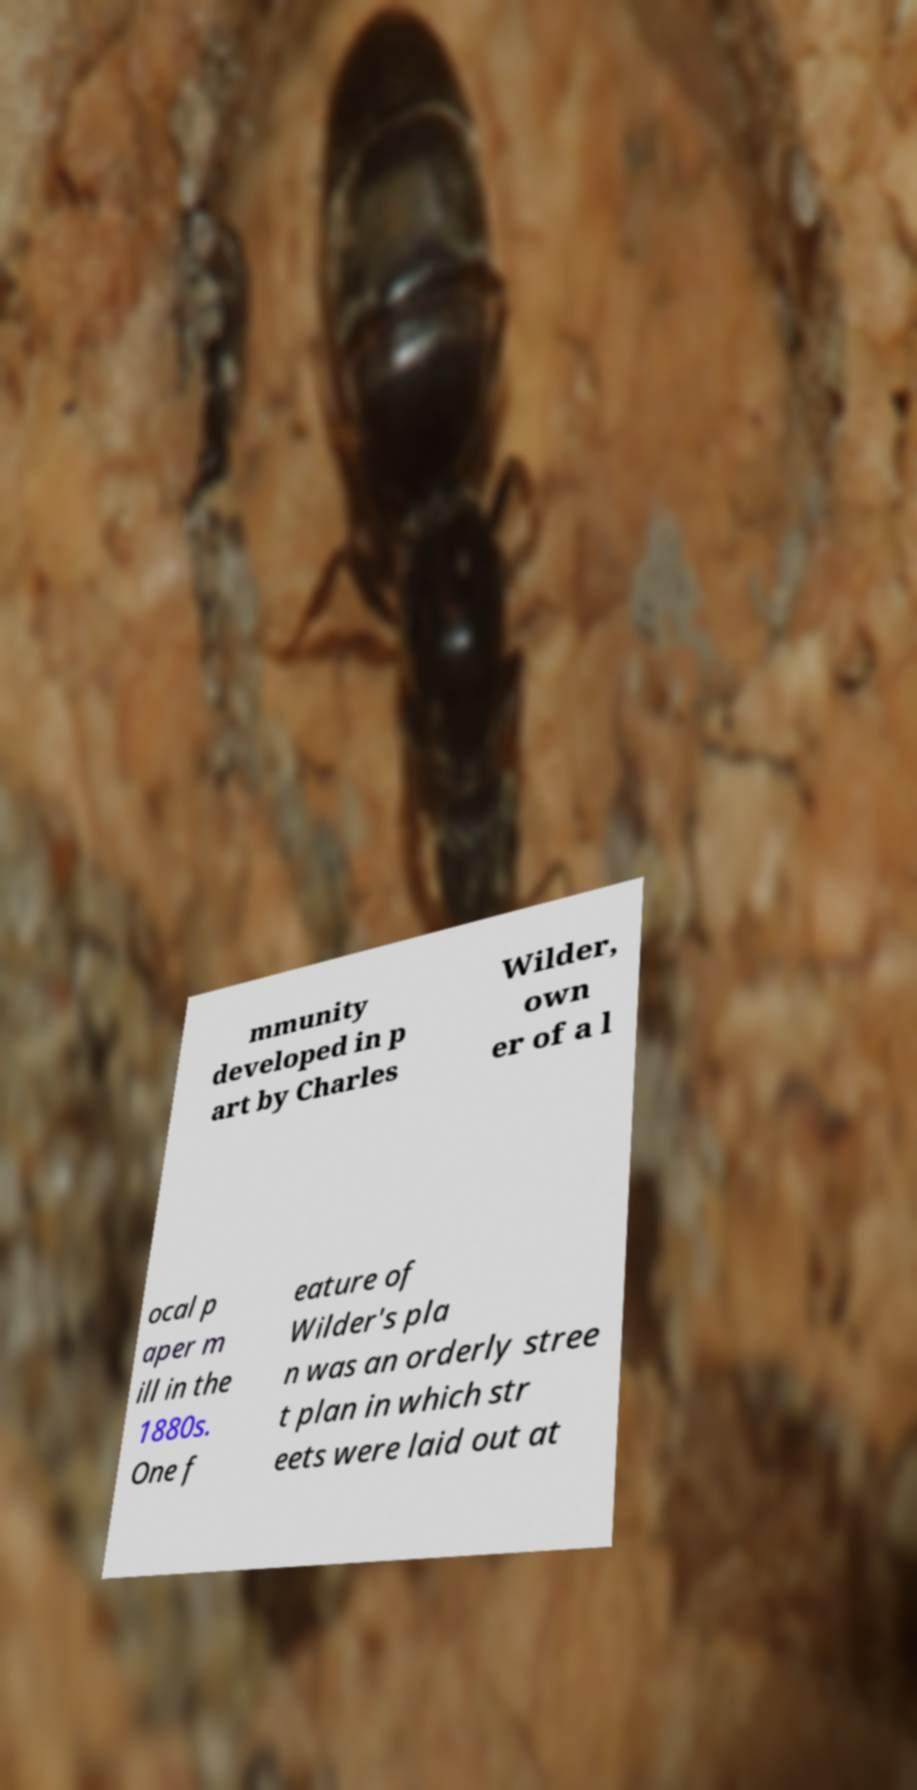Can you read and provide the text displayed in the image?This photo seems to have some interesting text. Can you extract and type it out for me? mmunity developed in p art by Charles Wilder, own er of a l ocal p aper m ill in the 1880s. One f eature of Wilder's pla n was an orderly stree t plan in which str eets were laid out at 